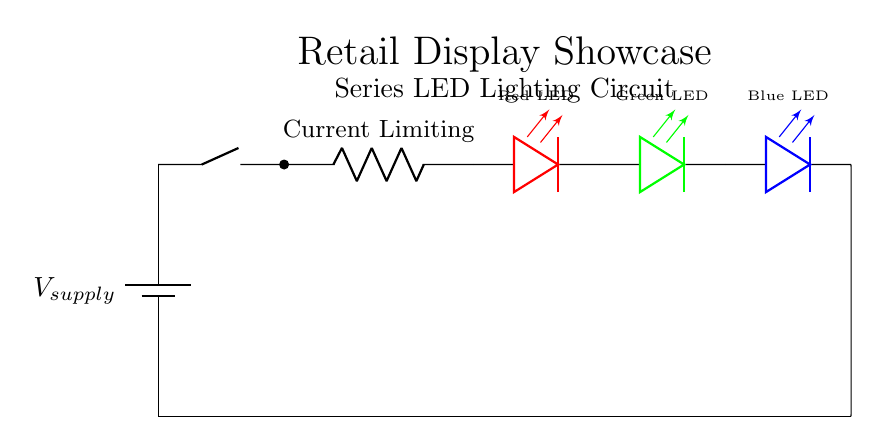What type of circuit is shown? The circuit is a series circuit, characterized by all components being connected along a single path, so the same current flows through each component.
Answer: series What components are used in this circuit? The circuit contains a battery, a switch, a resistor, and three LEDs (red, green, and blue). Each component can be visually identified in the diagram, confirming their presence.
Answer: battery, switch, resistor, red LED, green LED, blue LED What is the purpose of the resistor in this circuit? The purpose of the resistor is to limit the current flowing through the LEDs to prevent them from burning out, which is essential for their operation in a series configuration.
Answer: current limiting How many LEDs are present in the circuit? There are three LEDs in this circuit, which can be counted directly from the circuit diagram, where each LED is represented as a separate components in the series.
Answer: three What color is the first LED in the series? The first LED in the series is red, which can be identified from the color notation in the circuit diagram.
Answer: red How does the total voltage drop across the LEDs relate to the supply voltage? The total voltage drop across the LEDs must equal the supply voltage minus the voltage drop across the resistor; this is true in series circuits where the voltages add up to the source voltage.
Answer: total voltage drop equals supply voltage minus voltage drop across resistor What happens if one LED fails in this circuit? If one LED fails (open circuit), the entire circuit will stop working because, in a series circuit, all components must conduct for the current to flow.
Answer: circuit stops working 